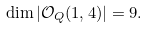Convert formula to latex. <formula><loc_0><loc_0><loc_500><loc_500>\dim | { \mathcal { O } } _ { Q } ( 1 , 4 ) | = 9 .</formula> 